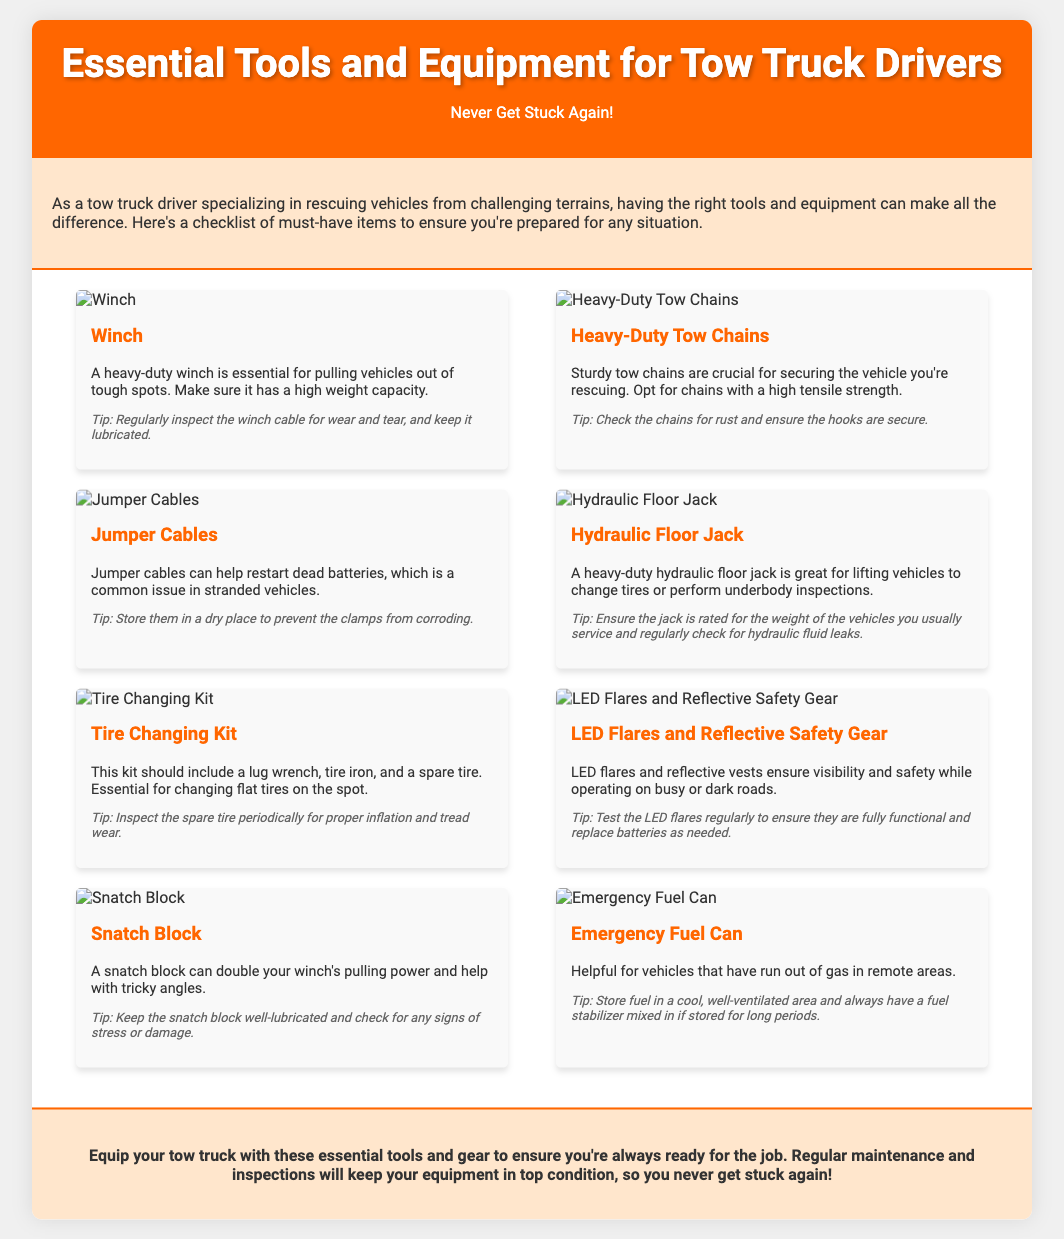What is the title of the flyer? The title of the flyer is prominently displayed at the top of the document.
Answer: Essential Tools and Equipment for Tow Truck Drivers What is the main purpose of the flyer? The purpose is stated in the introductory section of the document.
Answer: To provide a checklist of must-have items How many essential tools and equipment are listed? The number of items can be counted from the checklist section of the flyer.
Answer: Eight What is one recommended maintenance tip for the winch? The maintenance tip for the winch is specified in its description.
Answer: Regularly inspect the winch cable Which tool is suggested for changing flat tires? The specific tool for changing flat tires is mentioned in the checklist section.
Answer: Tire Changing Kit What color is the header background? The color of the header background can be observed in the rendered document.
Answer: Orange Which safety equipment is mentioned in the flyer? The document lists safety equipment in one of the checklist items.
Answer: Reflective Safety Gear What should be checked on heavy-duty tow chains? The recommended check for heavy-duty tow chains is included in the item description.
Answer: Check for rust What object helps to double the winch's pulling power? The item that enhances the winch's capability is specified.
Answer: Snatch Block What is one function of the emergency fuel can? The function of the emergency fuel can is described in the respective item's text.
Answer: For vehicles that have run out of gas 